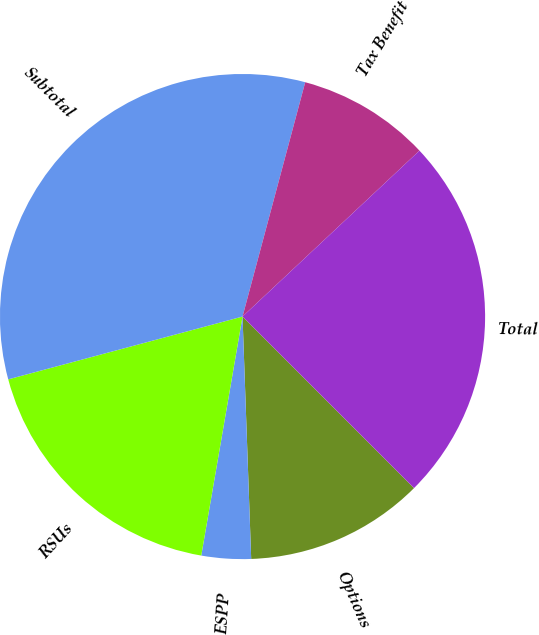Convert chart. <chart><loc_0><loc_0><loc_500><loc_500><pie_chart><fcel>Options<fcel>ESPP<fcel>RSUs<fcel>Subtotal<fcel>Tax Benefit<fcel>Total<nl><fcel>11.93%<fcel>3.29%<fcel>18.11%<fcel>33.33%<fcel>8.85%<fcel>24.49%<nl></chart> 